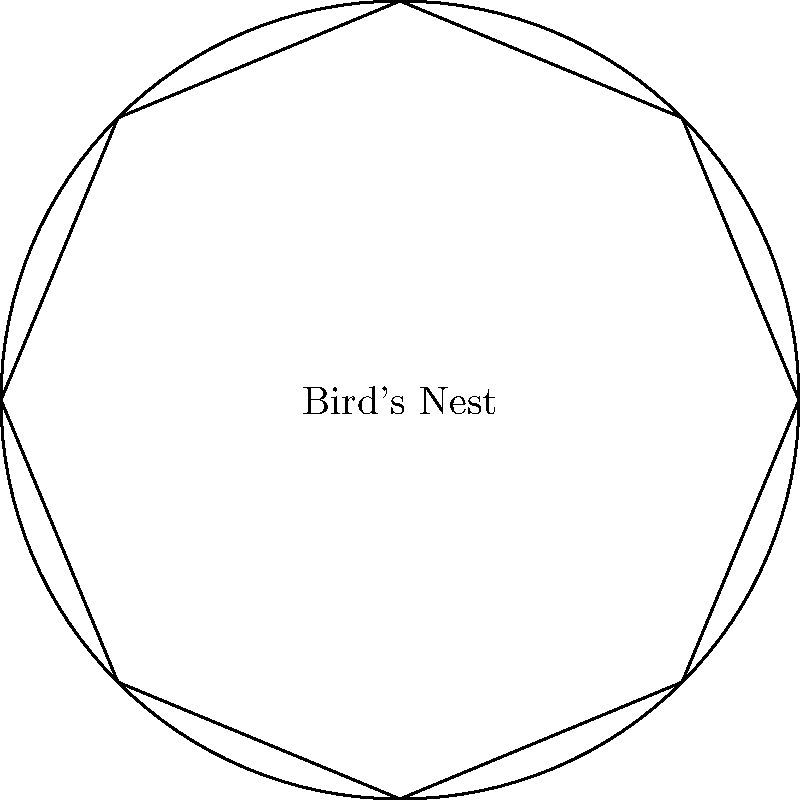The Beijing Olympic Stadium, known as the Bird's Nest, has a distinctive circular structure with eight intersecting steel beams, as shown in the simplified diagram. What is the order of the rotational symmetry group of this structure? To determine the order of the rotational symmetry group, we need to follow these steps:

1) Observe the structure: The Bird's Nest has a circular shape with 8 equally spaced intersecting beams.

2) Identify rotational symmetries: A rotation that brings the structure back to its original appearance is a symmetry.

3) Count distinct rotations:
   - 0° rotation (identity)
   - 45° rotation
   - 90° rotation
   - 135° rotation
   - 180° rotation
   - 225° rotation
   - 270° rotation
   - 315° rotation

4) The number of distinct rotations, including the identity rotation, gives us the order of the rotational symmetry group.

5) Count the total number of rotations: There are 8 distinct rotations that bring the structure back to its original appearance.

Therefore, the order of the rotational symmetry group is 8.

In group theory terms, this rotational symmetry group is isomorphic to the cyclic group $C_8$ or $\mathbb{Z}_8$.
Answer: 8 